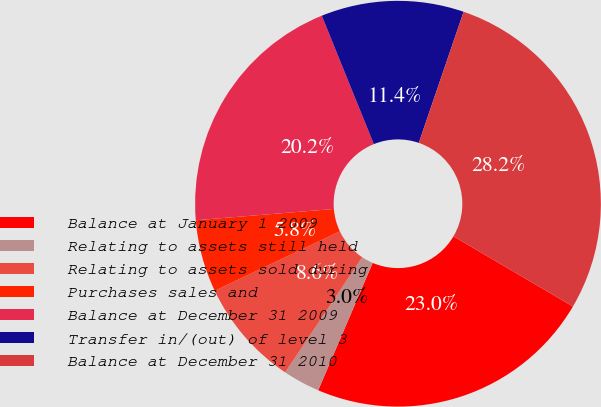Convert chart. <chart><loc_0><loc_0><loc_500><loc_500><pie_chart><fcel>Balance at January 1 2009<fcel>Relating to assets still held<fcel>Relating to assets sold during<fcel>Purchases sales and<fcel>Balance at December 31 2009<fcel>Transfer in/(out) of level 3<fcel>Balance at December 31 2010<nl><fcel>22.98%<fcel>2.95%<fcel>8.56%<fcel>5.76%<fcel>20.17%<fcel>11.37%<fcel>28.21%<nl></chart> 